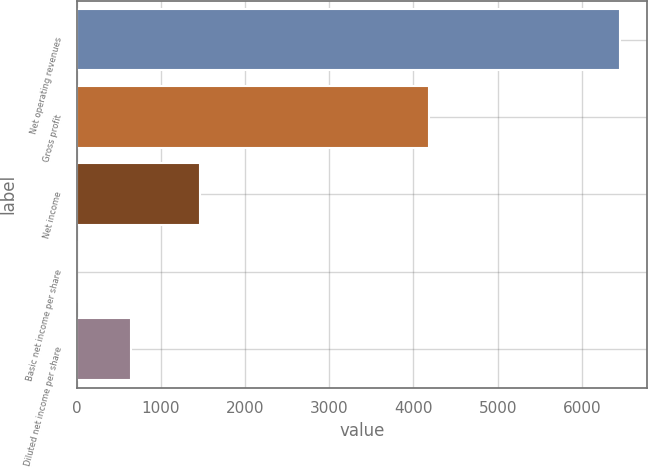<chart> <loc_0><loc_0><loc_500><loc_500><bar_chart><fcel>Net operating revenues<fcel>Gross profit<fcel>Net income<fcel>Basic net income per share<fcel>Diluted net income per share<nl><fcel>6454<fcel>4189<fcel>1460<fcel>0.62<fcel>645.96<nl></chart> 